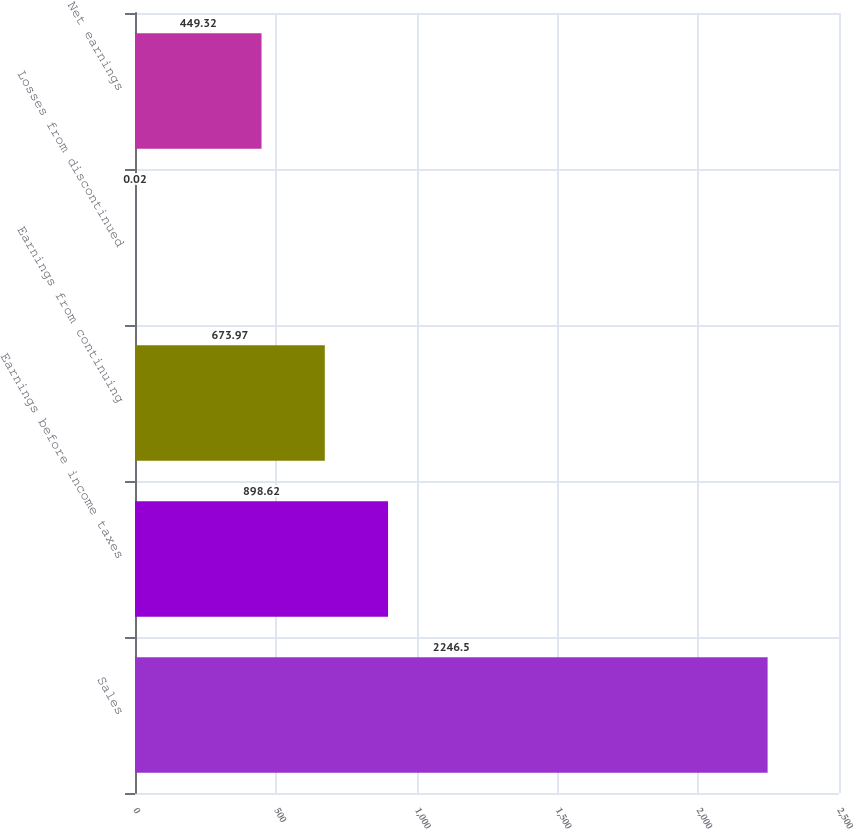Convert chart to OTSL. <chart><loc_0><loc_0><loc_500><loc_500><bar_chart><fcel>Sales<fcel>Earnings before income taxes<fcel>Earnings from continuing<fcel>Losses from discontinued<fcel>Net earnings<nl><fcel>2246.5<fcel>898.62<fcel>673.97<fcel>0.02<fcel>449.32<nl></chart> 